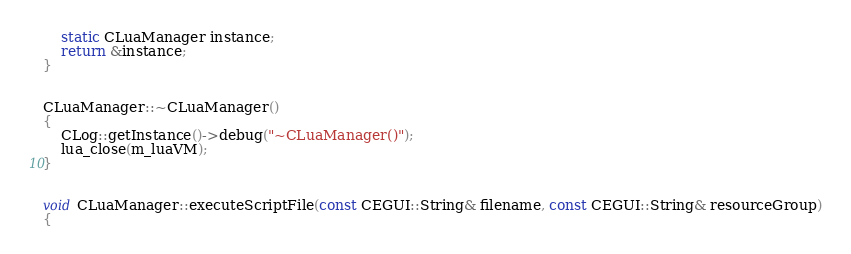Convert code to text. <code><loc_0><loc_0><loc_500><loc_500><_C++_>    static CLuaManager instance;
    return &instance;
}


CLuaManager::~CLuaManager()
{
    CLog::getInstance()->debug("~CLuaManager()");
    lua_close(m_luaVM);
}


void CLuaManager::executeScriptFile(const CEGUI::String& filename, const CEGUI::String& resourceGroup)
{</code> 